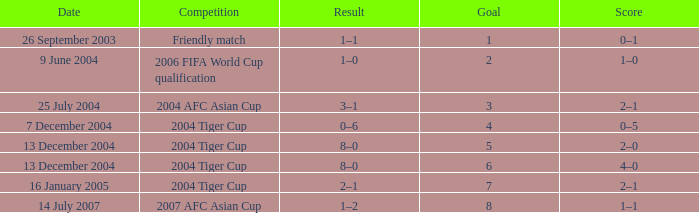Which date has 3 as the goal? 25 July 2004. 